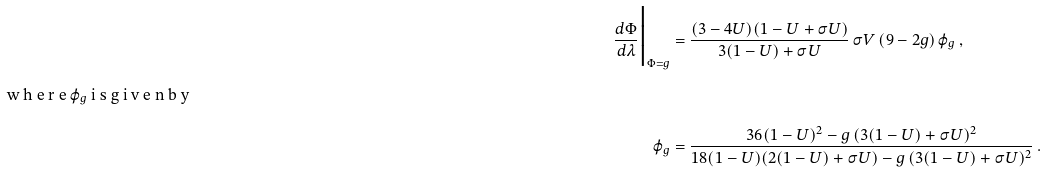<formula> <loc_0><loc_0><loc_500><loc_500>\frac { d \Phi } { d \lambda } \Big | _ { \Phi = g } & = \frac { ( 3 - 4 U ) ( 1 - U + \sigma U ) } { 3 ( 1 - U ) + \sigma U } \, \sigma V \, ( 9 - 2 g ) \, \varphi _ { g } \, , \intertext { w h e r e $ \varphi _ { g } $ i s g i v e n b y } \varphi _ { g } & = \frac { 3 6 ( 1 - U ) ^ { 2 } - g \, ( 3 ( 1 - U ) + \sigma U ) ^ { 2 } } { 1 8 ( 1 - U ) ( 2 ( 1 - U ) + \sigma U ) - g \, ( 3 ( 1 - U ) + \sigma U ) ^ { 2 } } \, .</formula> 